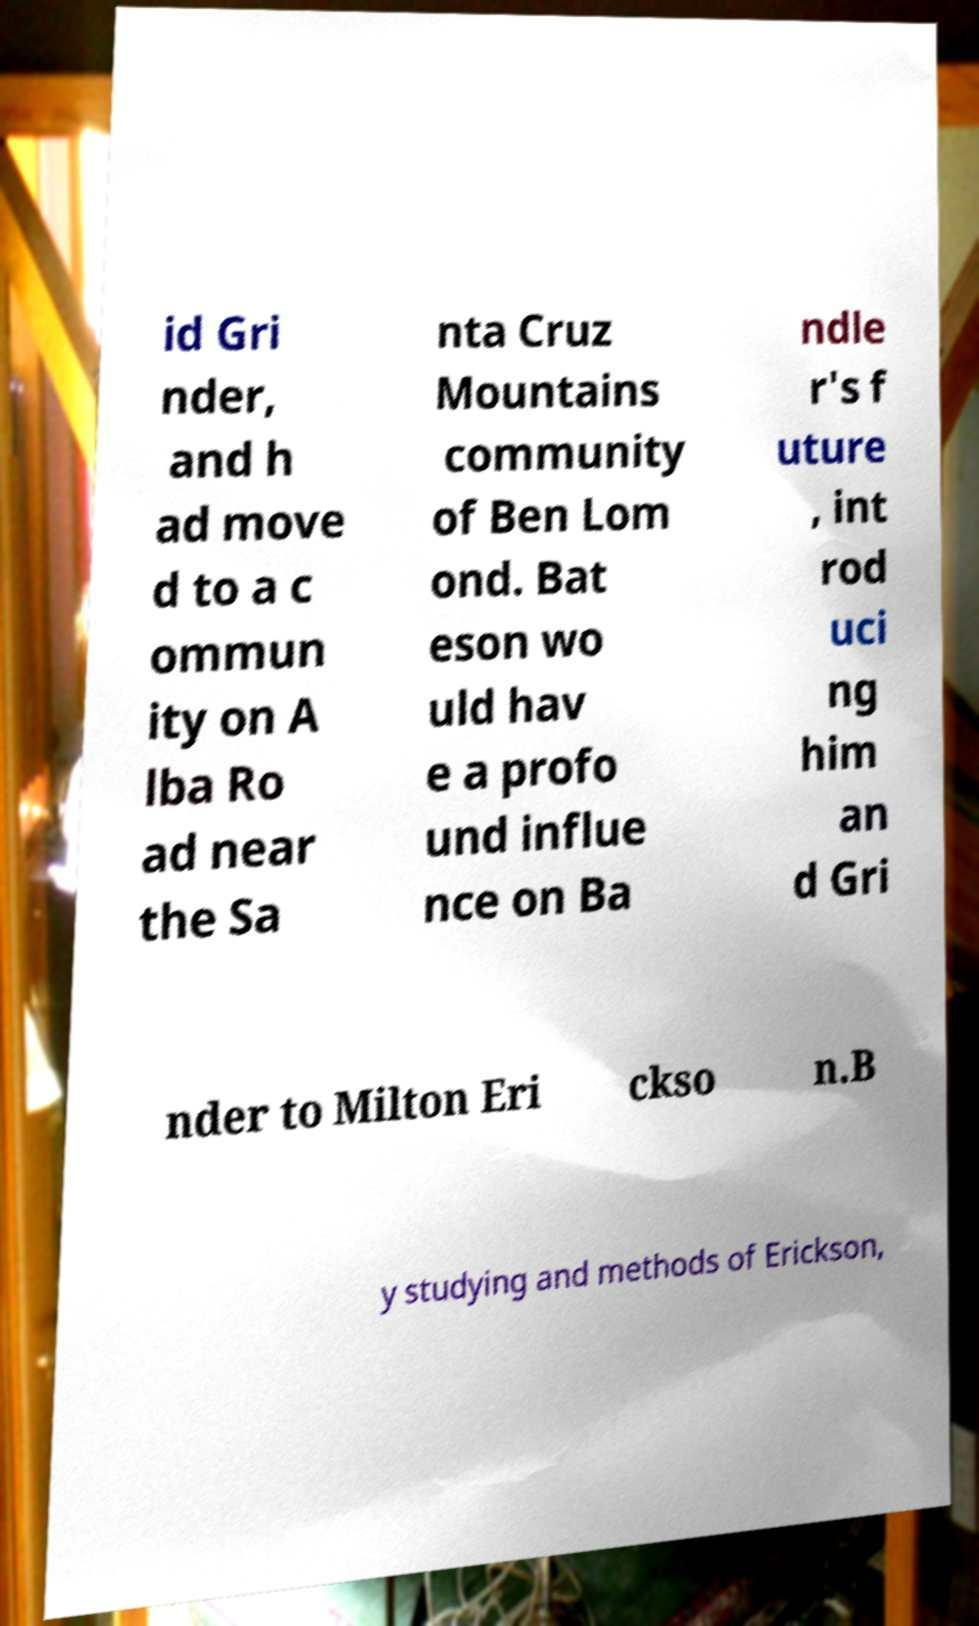Could you assist in decoding the text presented in this image and type it out clearly? id Gri nder, and h ad move d to a c ommun ity on A lba Ro ad near the Sa nta Cruz Mountains community of Ben Lom ond. Bat eson wo uld hav e a profo und influe nce on Ba ndle r's f uture , int rod uci ng him an d Gri nder to Milton Eri ckso n.B y studying and methods of Erickson, 